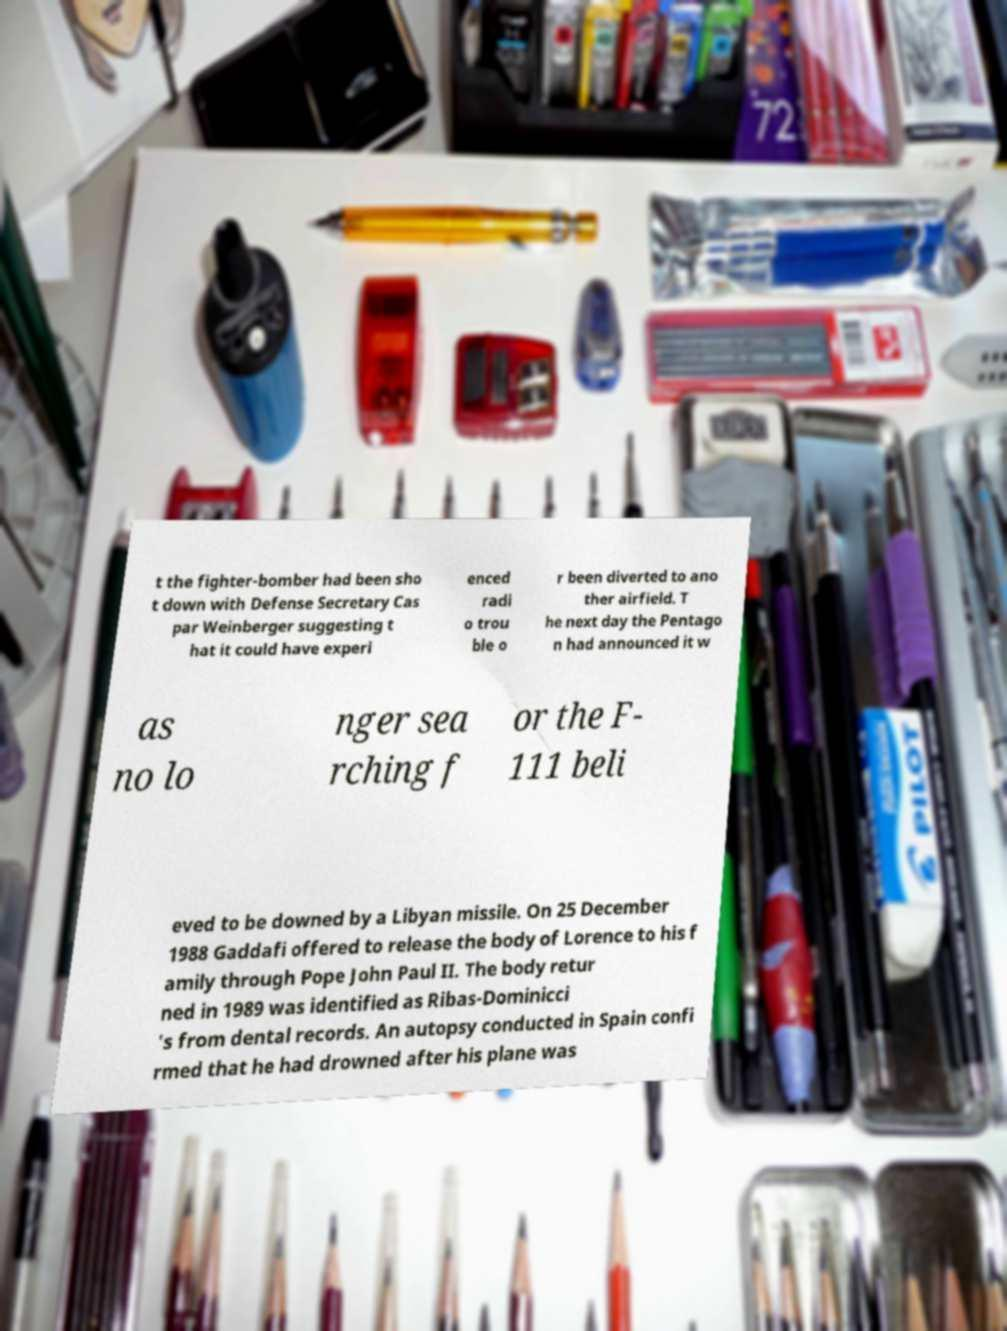There's text embedded in this image that I need extracted. Can you transcribe it verbatim? t the fighter-bomber had been sho t down with Defense Secretary Cas par Weinberger suggesting t hat it could have experi enced radi o trou ble o r been diverted to ano ther airfield. T he next day the Pentago n had announced it w as no lo nger sea rching f or the F- 111 beli eved to be downed by a Libyan missile. On 25 December 1988 Gaddafi offered to release the body of Lorence to his f amily through Pope John Paul II. The body retur ned in 1989 was identified as Ribas-Dominicci 's from dental records. An autopsy conducted in Spain confi rmed that he had drowned after his plane was 